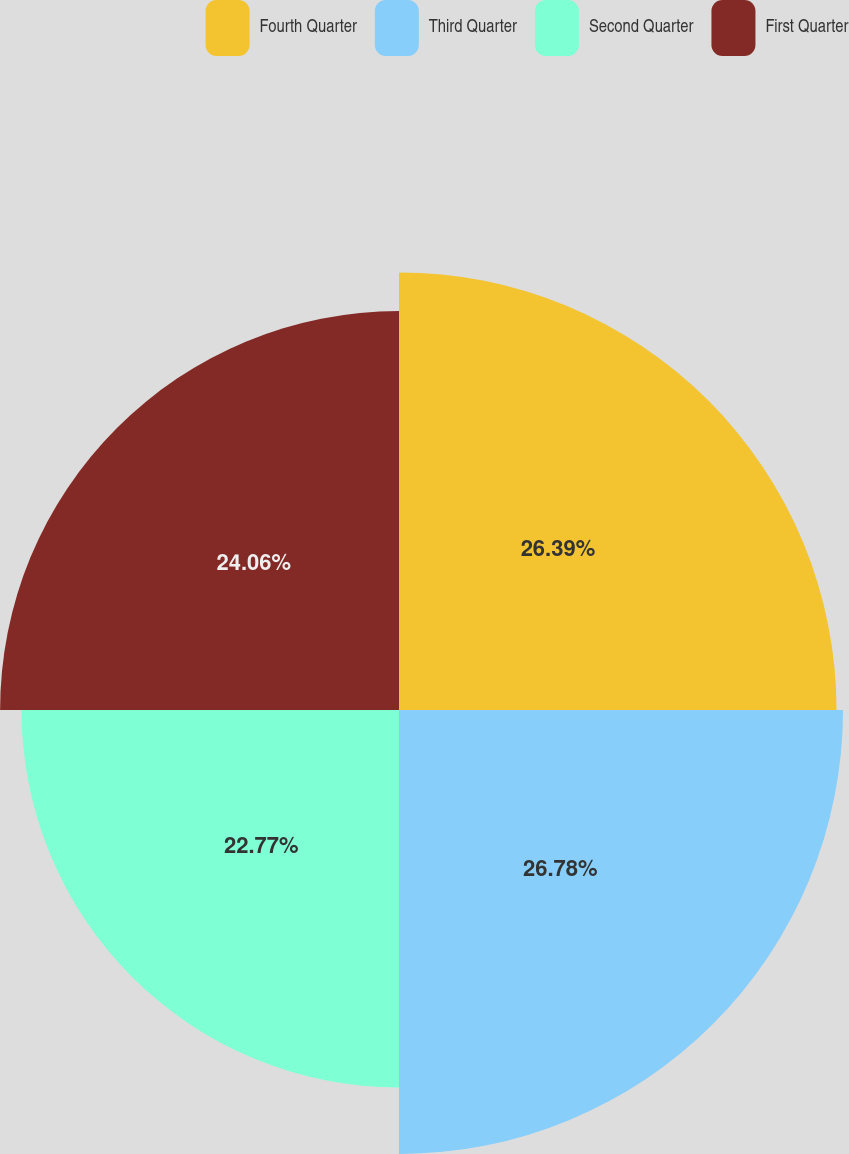<chart> <loc_0><loc_0><loc_500><loc_500><pie_chart><fcel>Fourth Quarter<fcel>Third Quarter<fcel>Second Quarter<fcel>First Quarter<nl><fcel>26.39%<fcel>26.78%<fcel>22.77%<fcel>24.06%<nl></chart> 